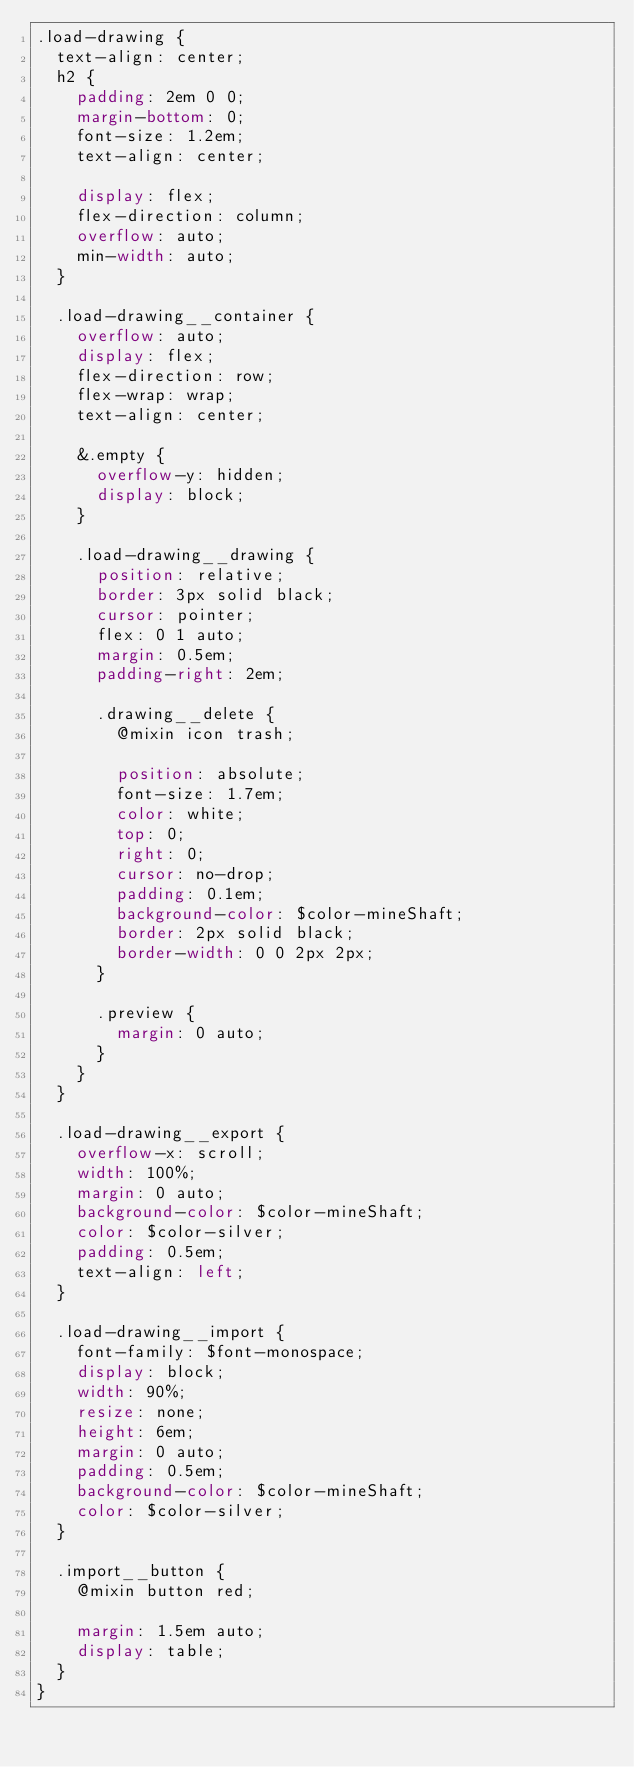<code> <loc_0><loc_0><loc_500><loc_500><_CSS_>.load-drawing {
  text-align: center;
  h2 {
    padding: 2em 0 0;
    margin-bottom: 0;
    font-size: 1.2em;
    text-align: center;

    display: flex;
    flex-direction: column;
    overflow: auto;
    min-width: auto;
  }

  .load-drawing__container {
    overflow: auto;
    display: flex;
    flex-direction: row;
    flex-wrap: wrap;
    text-align: center;

    &.empty {
      overflow-y: hidden;
      display: block;
    }

    .load-drawing__drawing {
      position: relative;
      border: 3px solid black;
      cursor: pointer;
      flex: 0 1 auto;
      margin: 0.5em;
      padding-right: 2em;

      .drawing__delete {
        @mixin icon trash;

        position: absolute;
        font-size: 1.7em;
        color: white;
        top: 0;
        right: 0;
        cursor: no-drop;
        padding: 0.1em;
        background-color: $color-mineShaft;
        border: 2px solid black;
        border-width: 0 0 2px 2px;
      }

      .preview {
        margin: 0 auto;
      }
    }
  }

  .load-drawing__export {
    overflow-x: scroll;
    width: 100%;
    margin: 0 auto;
    background-color: $color-mineShaft;
    color: $color-silver;
    padding: 0.5em;
    text-align: left;
  }

  .load-drawing__import {
    font-family: $font-monospace;
    display: block;
    width: 90%;
    resize: none;
    height: 6em;
    margin: 0 auto;
    padding: 0.5em;
    background-color: $color-mineShaft;
    color: $color-silver;
  }

  .import__button {
    @mixin button red;

    margin: 1.5em auto;
    display: table;
  }
}
</code> 